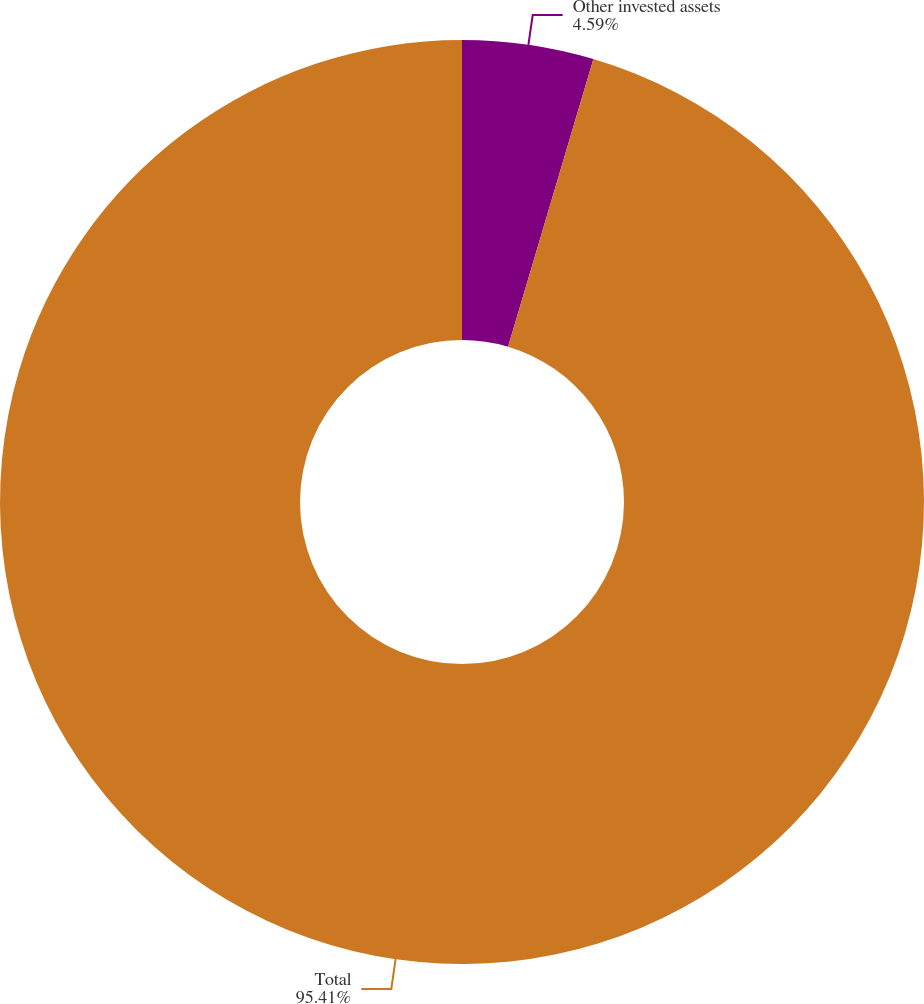Convert chart to OTSL. <chart><loc_0><loc_0><loc_500><loc_500><pie_chart><fcel>Other invested assets<fcel>Total<nl><fcel>4.59%<fcel>95.41%<nl></chart> 